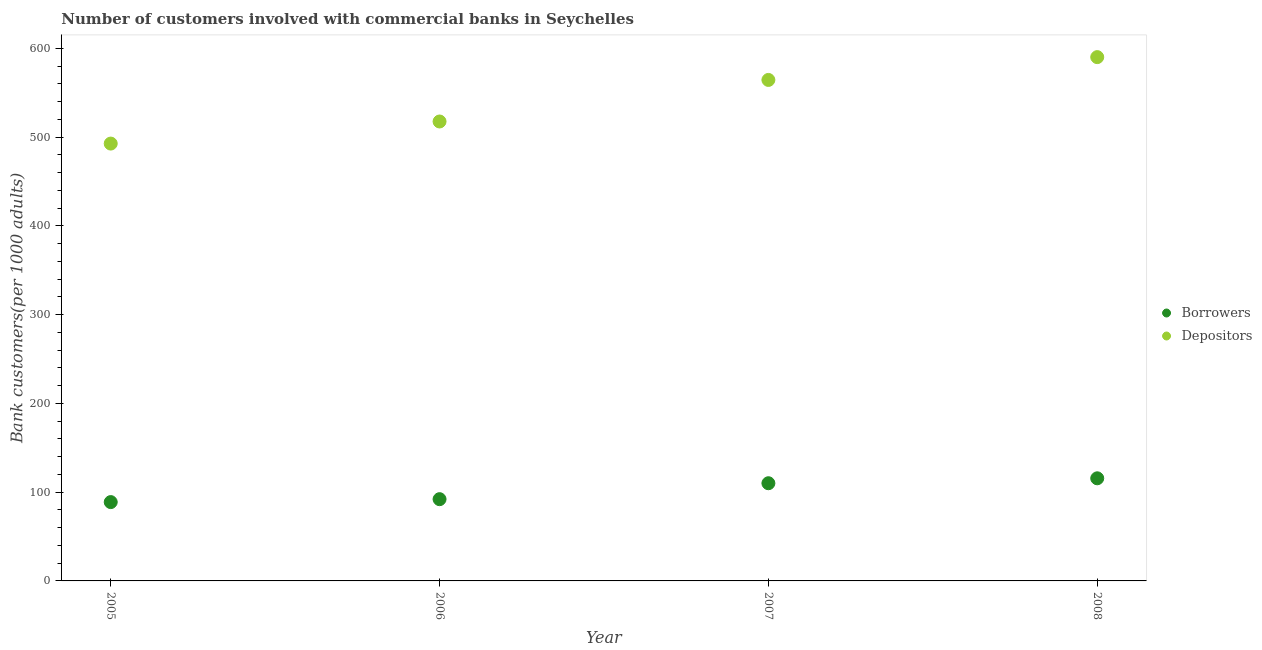What is the number of depositors in 2005?
Your response must be concise. 492.72. Across all years, what is the maximum number of depositors?
Keep it short and to the point. 590.13. Across all years, what is the minimum number of borrowers?
Offer a very short reply. 88.81. What is the total number of depositors in the graph?
Offer a terse response. 2164.88. What is the difference between the number of borrowers in 2007 and that in 2008?
Offer a very short reply. -5.55. What is the difference between the number of borrowers in 2008 and the number of depositors in 2005?
Your response must be concise. -377.11. What is the average number of depositors per year?
Make the answer very short. 541.22. In the year 2006, what is the difference between the number of depositors and number of borrowers?
Offer a terse response. 425.51. In how many years, is the number of depositors greater than 340?
Keep it short and to the point. 4. What is the ratio of the number of depositors in 2005 to that in 2008?
Make the answer very short. 0.83. Is the number of depositors in 2005 less than that in 2006?
Ensure brevity in your answer.  Yes. What is the difference between the highest and the second highest number of borrowers?
Offer a terse response. 5.55. What is the difference between the highest and the lowest number of depositors?
Give a very brief answer. 97.4. In how many years, is the number of depositors greater than the average number of depositors taken over all years?
Your answer should be compact. 2. Is the sum of the number of borrowers in 2006 and 2007 greater than the maximum number of depositors across all years?
Your answer should be compact. No. Is the number of borrowers strictly greater than the number of depositors over the years?
Offer a very short reply. No. Is the number of borrowers strictly less than the number of depositors over the years?
Your answer should be compact. Yes. What is the difference between two consecutive major ticks on the Y-axis?
Provide a succinct answer. 100. Where does the legend appear in the graph?
Your answer should be compact. Center right. How many legend labels are there?
Your response must be concise. 2. What is the title of the graph?
Make the answer very short. Number of customers involved with commercial banks in Seychelles. Does "Males" appear as one of the legend labels in the graph?
Your answer should be very brief. No. What is the label or title of the X-axis?
Your response must be concise. Year. What is the label or title of the Y-axis?
Provide a short and direct response. Bank customers(per 1000 adults). What is the Bank customers(per 1000 adults) of Borrowers in 2005?
Ensure brevity in your answer.  88.81. What is the Bank customers(per 1000 adults) in Depositors in 2005?
Make the answer very short. 492.72. What is the Bank customers(per 1000 adults) of Borrowers in 2006?
Make the answer very short. 92.1. What is the Bank customers(per 1000 adults) in Depositors in 2006?
Offer a very short reply. 517.61. What is the Bank customers(per 1000 adults) of Borrowers in 2007?
Provide a succinct answer. 110.06. What is the Bank customers(per 1000 adults) of Depositors in 2007?
Give a very brief answer. 564.42. What is the Bank customers(per 1000 adults) of Borrowers in 2008?
Make the answer very short. 115.61. What is the Bank customers(per 1000 adults) in Depositors in 2008?
Provide a succinct answer. 590.13. Across all years, what is the maximum Bank customers(per 1000 adults) in Borrowers?
Provide a short and direct response. 115.61. Across all years, what is the maximum Bank customers(per 1000 adults) of Depositors?
Provide a succinct answer. 590.13. Across all years, what is the minimum Bank customers(per 1000 adults) of Borrowers?
Your answer should be compact. 88.81. Across all years, what is the minimum Bank customers(per 1000 adults) in Depositors?
Ensure brevity in your answer.  492.72. What is the total Bank customers(per 1000 adults) of Borrowers in the graph?
Keep it short and to the point. 406.58. What is the total Bank customers(per 1000 adults) in Depositors in the graph?
Your response must be concise. 2164.88. What is the difference between the Bank customers(per 1000 adults) of Borrowers in 2005 and that in 2006?
Make the answer very short. -3.29. What is the difference between the Bank customers(per 1000 adults) of Depositors in 2005 and that in 2006?
Provide a short and direct response. -24.89. What is the difference between the Bank customers(per 1000 adults) in Borrowers in 2005 and that in 2007?
Keep it short and to the point. -21.25. What is the difference between the Bank customers(per 1000 adults) of Depositors in 2005 and that in 2007?
Provide a short and direct response. -71.7. What is the difference between the Bank customers(per 1000 adults) of Borrowers in 2005 and that in 2008?
Your answer should be very brief. -26.8. What is the difference between the Bank customers(per 1000 adults) of Depositors in 2005 and that in 2008?
Make the answer very short. -97.4. What is the difference between the Bank customers(per 1000 adults) of Borrowers in 2006 and that in 2007?
Your answer should be compact. -17.96. What is the difference between the Bank customers(per 1000 adults) in Depositors in 2006 and that in 2007?
Make the answer very short. -46.82. What is the difference between the Bank customers(per 1000 adults) in Borrowers in 2006 and that in 2008?
Your response must be concise. -23.51. What is the difference between the Bank customers(per 1000 adults) in Depositors in 2006 and that in 2008?
Offer a terse response. -72.52. What is the difference between the Bank customers(per 1000 adults) in Borrowers in 2007 and that in 2008?
Give a very brief answer. -5.55. What is the difference between the Bank customers(per 1000 adults) of Depositors in 2007 and that in 2008?
Your answer should be compact. -25.7. What is the difference between the Bank customers(per 1000 adults) of Borrowers in 2005 and the Bank customers(per 1000 adults) of Depositors in 2006?
Offer a terse response. -428.8. What is the difference between the Bank customers(per 1000 adults) of Borrowers in 2005 and the Bank customers(per 1000 adults) of Depositors in 2007?
Your answer should be very brief. -475.62. What is the difference between the Bank customers(per 1000 adults) in Borrowers in 2005 and the Bank customers(per 1000 adults) in Depositors in 2008?
Your answer should be very brief. -501.32. What is the difference between the Bank customers(per 1000 adults) in Borrowers in 2006 and the Bank customers(per 1000 adults) in Depositors in 2007?
Offer a terse response. -472.32. What is the difference between the Bank customers(per 1000 adults) in Borrowers in 2006 and the Bank customers(per 1000 adults) in Depositors in 2008?
Ensure brevity in your answer.  -498.02. What is the difference between the Bank customers(per 1000 adults) of Borrowers in 2007 and the Bank customers(per 1000 adults) of Depositors in 2008?
Your answer should be very brief. -480.07. What is the average Bank customers(per 1000 adults) in Borrowers per year?
Your answer should be compact. 101.64. What is the average Bank customers(per 1000 adults) in Depositors per year?
Keep it short and to the point. 541.22. In the year 2005, what is the difference between the Bank customers(per 1000 adults) in Borrowers and Bank customers(per 1000 adults) in Depositors?
Your answer should be compact. -403.91. In the year 2006, what is the difference between the Bank customers(per 1000 adults) in Borrowers and Bank customers(per 1000 adults) in Depositors?
Your response must be concise. -425.51. In the year 2007, what is the difference between the Bank customers(per 1000 adults) in Borrowers and Bank customers(per 1000 adults) in Depositors?
Your response must be concise. -454.37. In the year 2008, what is the difference between the Bank customers(per 1000 adults) of Borrowers and Bank customers(per 1000 adults) of Depositors?
Ensure brevity in your answer.  -474.52. What is the ratio of the Bank customers(per 1000 adults) of Borrowers in 2005 to that in 2006?
Provide a succinct answer. 0.96. What is the ratio of the Bank customers(per 1000 adults) in Depositors in 2005 to that in 2006?
Your answer should be very brief. 0.95. What is the ratio of the Bank customers(per 1000 adults) in Borrowers in 2005 to that in 2007?
Your response must be concise. 0.81. What is the ratio of the Bank customers(per 1000 adults) in Depositors in 2005 to that in 2007?
Keep it short and to the point. 0.87. What is the ratio of the Bank customers(per 1000 adults) in Borrowers in 2005 to that in 2008?
Ensure brevity in your answer.  0.77. What is the ratio of the Bank customers(per 1000 adults) of Depositors in 2005 to that in 2008?
Give a very brief answer. 0.83. What is the ratio of the Bank customers(per 1000 adults) in Borrowers in 2006 to that in 2007?
Make the answer very short. 0.84. What is the ratio of the Bank customers(per 1000 adults) in Depositors in 2006 to that in 2007?
Offer a terse response. 0.92. What is the ratio of the Bank customers(per 1000 adults) in Borrowers in 2006 to that in 2008?
Offer a terse response. 0.8. What is the ratio of the Bank customers(per 1000 adults) in Depositors in 2006 to that in 2008?
Make the answer very short. 0.88. What is the ratio of the Bank customers(per 1000 adults) in Depositors in 2007 to that in 2008?
Make the answer very short. 0.96. What is the difference between the highest and the second highest Bank customers(per 1000 adults) of Borrowers?
Provide a succinct answer. 5.55. What is the difference between the highest and the second highest Bank customers(per 1000 adults) of Depositors?
Provide a succinct answer. 25.7. What is the difference between the highest and the lowest Bank customers(per 1000 adults) in Borrowers?
Your response must be concise. 26.8. What is the difference between the highest and the lowest Bank customers(per 1000 adults) in Depositors?
Ensure brevity in your answer.  97.4. 